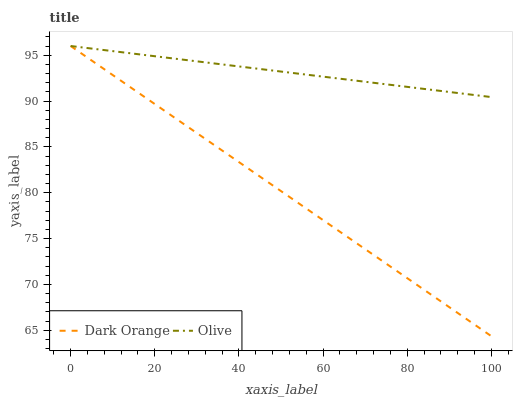Does Dark Orange have the maximum area under the curve?
Answer yes or no. No. Is Dark Orange the roughest?
Answer yes or no. No. 